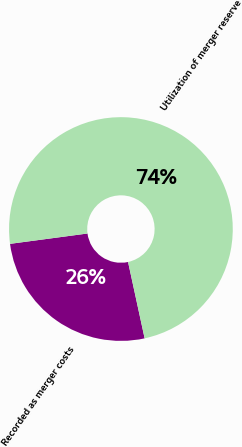Convert chart. <chart><loc_0><loc_0><loc_500><loc_500><pie_chart><fcel>Recorded as merger costs<fcel>Utilization of merger reserve<nl><fcel>26.29%<fcel>73.71%<nl></chart> 